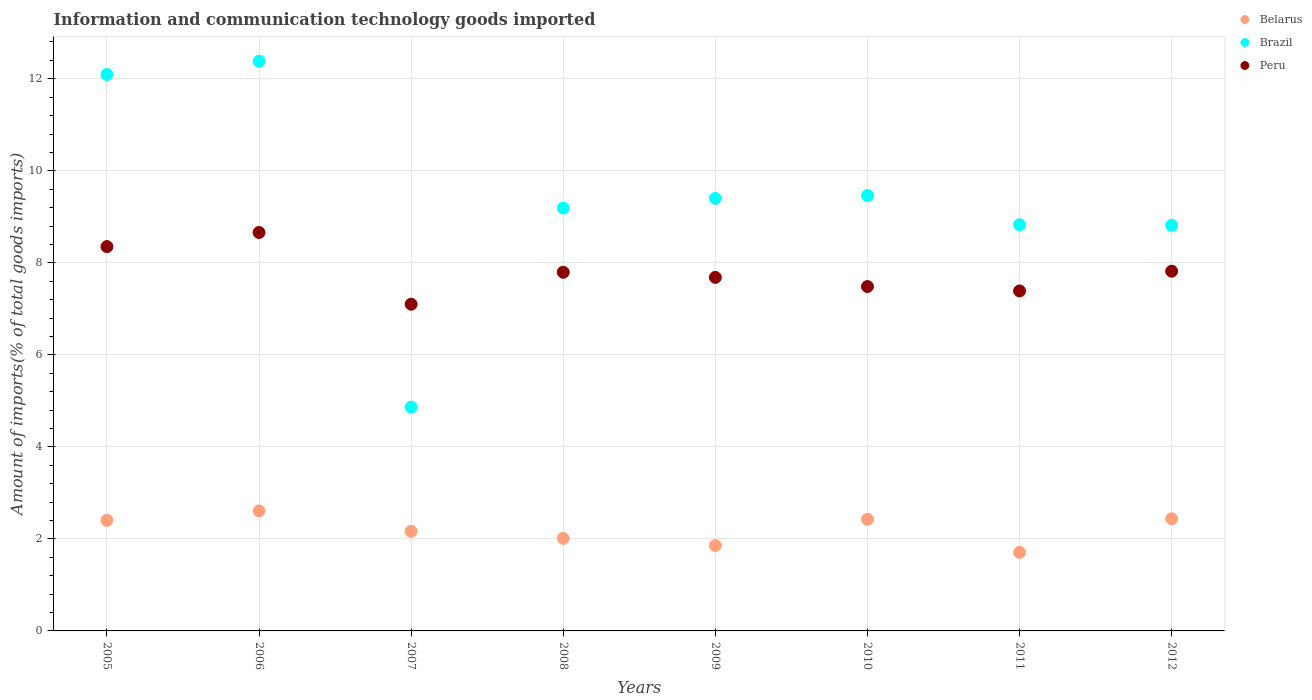Is the number of dotlines equal to the number of legend labels?
Keep it short and to the point. Yes. What is the amount of goods imported in Brazil in 2011?
Make the answer very short. 8.83. Across all years, what is the maximum amount of goods imported in Belarus?
Ensure brevity in your answer.  2.61. Across all years, what is the minimum amount of goods imported in Belarus?
Give a very brief answer. 1.71. In which year was the amount of goods imported in Brazil maximum?
Provide a succinct answer. 2006. What is the total amount of goods imported in Peru in the graph?
Ensure brevity in your answer.  62.29. What is the difference between the amount of goods imported in Peru in 2006 and that in 2007?
Give a very brief answer. 1.56. What is the difference between the amount of goods imported in Brazil in 2008 and the amount of goods imported in Belarus in 2009?
Provide a succinct answer. 7.34. What is the average amount of goods imported in Belarus per year?
Make the answer very short. 2.2. In the year 2008, what is the difference between the amount of goods imported in Belarus and amount of goods imported in Brazil?
Give a very brief answer. -7.18. In how many years, is the amount of goods imported in Peru greater than 4.8 %?
Your response must be concise. 8. What is the ratio of the amount of goods imported in Belarus in 2007 to that in 2011?
Make the answer very short. 1.27. Is the amount of goods imported in Peru in 2005 less than that in 2009?
Your answer should be very brief. No. What is the difference between the highest and the second highest amount of goods imported in Belarus?
Provide a short and direct response. 0.17. What is the difference between the highest and the lowest amount of goods imported in Belarus?
Make the answer very short. 0.9. In how many years, is the amount of goods imported in Belarus greater than the average amount of goods imported in Belarus taken over all years?
Make the answer very short. 4. Is the sum of the amount of goods imported in Belarus in 2006 and 2009 greater than the maximum amount of goods imported in Brazil across all years?
Your answer should be compact. No. Is it the case that in every year, the sum of the amount of goods imported in Peru and amount of goods imported in Belarus  is greater than the amount of goods imported in Brazil?
Offer a terse response. No. How many dotlines are there?
Offer a terse response. 3. Where does the legend appear in the graph?
Provide a succinct answer. Top right. What is the title of the graph?
Your answer should be compact. Information and communication technology goods imported. Does "Guam" appear as one of the legend labels in the graph?
Make the answer very short. No. What is the label or title of the X-axis?
Make the answer very short. Years. What is the label or title of the Y-axis?
Keep it short and to the point. Amount of imports(% of total goods imports). What is the Amount of imports(% of total goods imports) of Belarus in 2005?
Your answer should be very brief. 2.4. What is the Amount of imports(% of total goods imports) of Brazil in 2005?
Your answer should be compact. 12.1. What is the Amount of imports(% of total goods imports) in Peru in 2005?
Make the answer very short. 8.35. What is the Amount of imports(% of total goods imports) in Belarus in 2006?
Make the answer very short. 2.61. What is the Amount of imports(% of total goods imports) in Brazil in 2006?
Offer a terse response. 12.38. What is the Amount of imports(% of total goods imports) in Peru in 2006?
Your answer should be compact. 8.66. What is the Amount of imports(% of total goods imports) in Belarus in 2007?
Your answer should be compact. 2.17. What is the Amount of imports(% of total goods imports) in Brazil in 2007?
Offer a very short reply. 4.87. What is the Amount of imports(% of total goods imports) in Peru in 2007?
Offer a terse response. 7.1. What is the Amount of imports(% of total goods imports) of Belarus in 2008?
Your answer should be very brief. 2.01. What is the Amount of imports(% of total goods imports) in Brazil in 2008?
Ensure brevity in your answer.  9.19. What is the Amount of imports(% of total goods imports) in Peru in 2008?
Provide a short and direct response. 7.8. What is the Amount of imports(% of total goods imports) in Belarus in 2009?
Keep it short and to the point. 1.85. What is the Amount of imports(% of total goods imports) in Brazil in 2009?
Offer a very short reply. 9.4. What is the Amount of imports(% of total goods imports) in Peru in 2009?
Ensure brevity in your answer.  7.68. What is the Amount of imports(% of total goods imports) in Belarus in 2010?
Your response must be concise. 2.43. What is the Amount of imports(% of total goods imports) of Brazil in 2010?
Offer a very short reply. 9.46. What is the Amount of imports(% of total goods imports) of Peru in 2010?
Keep it short and to the point. 7.48. What is the Amount of imports(% of total goods imports) in Belarus in 2011?
Make the answer very short. 1.71. What is the Amount of imports(% of total goods imports) of Brazil in 2011?
Make the answer very short. 8.83. What is the Amount of imports(% of total goods imports) in Peru in 2011?
Offer a terse response. 7.39. What is the Amount of imports(% of total goods imports) of Belarus in 2012?
Keep it short and to the point. 2.44. What is the Amount of imports(% of total goods imports) of Brazil in 2012?
Keep it short and to the point. 8.82. What is the Amount of imports(% of total goods imports) in Peru in 2012?
Provide a succinct answer. 7.82. Across all years, what is the maximum Amount of imports(% of total goods imports) of Belarus?
Keep it short and to the point. 2.61. Across all years, what is the maximum Amount of imports(% of total goods imports) in Brazil?
Give a very brief answer. 12.38. Across all years, what is the maximum Amount of imports(% of total goods imports) of Peru?
Give a very brief answer. 8.66. Across all years, what is the minimum Amount of imports(% of total goods imports) of Belarus?
Offer a terse response. 1.71. Across all years, what is the minimum Amount of imports(% of total goods imports) of Brazil?
Provide a short and direct response. 4.87. Across all years, what is the minimum Amount of imports(% of total goods imports) of Peru?
Offer a very short reply. 7.1. What is the total Amount of imports(% of total goods imports) of Belarus in the graph?
Provide a short and direct response. 17.61. What is the total Amount of imports(% of total goods imports) of Brazil in the graph?
Ensure brevity in your answer.  75.04. What is the total Amount of imports(% of total goods imports) in Peru in the graph?
Your answer should be compact. 62.29. What is the difference between the Amount of imports(% of total goods imports) in Belarus in 2005 and that in 2006?
Provide a succinct answer. -0.2. What is the difference between the Amount of imports(% of total goods imports) of Brazil in 2005 and that in 2006?
Offer a very short reply. -0.29. What is the difference between the Amount of imports(% of total goods imports) in Peru in 2005 and that in 2006?
Your answer should be compact. -0.31. What is the difference between the Amount of imports(% of total goods imports) in Belarus in 2005 and that in 2007?
Give a very brief answer. 0.24. What is the difference between the Amount of imports(% of total goods imports) of Brazil in 2005 and that in 2007?
Give a very brief answer. 7.23. What is the difference between the Amount of imports(% of total goods imports) in Peru in 2005 and that in 2007?
Provide a short and direct response. 1.25. What is the difference between the Amount of imports(% of total goods imports) in Belarus in 2005 and that in 2008?
Offer a terse response. 0.39. What is the difference between the Amount of imports(% of total goods imports) in Brazil in 2005 and that in 2008?
Provide a short and direct response. 2.9. What is the difference between the Amount of imports(% of total goods imports) of Peru in 2005 and that in 2008?
Your answer should be very brief. 0.56. What is the difference between the Amount of imports(% of total goods imports) of Belarus in 2005 and that in 2009?
Make the answer very short. 0.55. What is the difference between the Amount of imports(% of total goods imports) of Brazil in 2005 and that in 2009?
Offer a very short reply. 2.69. What is the difference between the Amount of imports(% of total goods imports) in Peru in 2005 and that in 2009?
Make the answer very short. 0.67. What is the difference between the Amount of imports(% of total goods imports) in Belarus in 2005 and that in 2010?
Provide a succinct answer. -0.02. What is the difference between the Amount of imports(% of total goods imports) of Brazil in 2005 and that in 2010?
Provide a succinct answer. 2.63. What is the difference between the Amount of imports(% of total goods imports) of Peru in 2005 and that in 2010?
Offer a very short reply. 0.87. What is the difference between the Amount of imports(% of total goods imports) of Belarus in 2005 and that in 2011?
Offer a very short reply. 0.7. What is the difference between the Amount of imports(% of total goods imports) in Brazil in 2005 and that in 2011?
Your answer should be compact. 3.27. What is the difference between the Amount of imports(% of total goods imports) of Peru in 2005 and that in 2011?
Offer a very short reply. 0.96. What is the difference between the Amount of imports(% of total goods imports) in Belarus in 2005 and that in 2012?
Offer a very short reply. -0.04. What is the difference between the Amount of imports(% of total goods imports) of Brazil in 2005 and that in 2012?
Your response must be concise. 3.28. What is the difference between the Amount of imports(% of total goods imports) in Peru in 2005 and that in 2012?
Make the answer very short. 0.54. What is the difference between the Amount of imports(% of total goods imports) in Belarus in 2006 and that in 2007?
Provide a succinct answer. 0.44. What is the difference between the Amount of imports(% of total goods imports) in Brazil in 2006 and that in 2007?
Offer a very short reply. 7.52. What is the difference between the Amount of imports(% of total goods imports) in Peru in 2006 and that in 2007?
Make the answer very short. 1.56. What is the difference between the Amount of imports(% of total goods imports) in Belarus in 2006 and that in 2008?
Make the answer very short. 0.6. What is the difference between the Amount of imports(% of total goods imports) of Brazil in 2006 and that in 2008?
Your answer should be compact. 3.19. What is the difference between the Amount of imports(% of total goods imports) in Peru in 2006 and that in 2008?
Your answer should be compact. 0.86. What is the difference between the Amount of imports(% of total goods imports) in Belarus in 2006 and that in 2009?
Ensure brevity in your answer.  0.75. What is the difference between the Amount of imports(% of total goods imports) in Brazil in 2006 and that in 2009?
Offer a terse response. 2.98. What is the difference between the Amount of imports(% of total goods imports) in Peru in 2006 and that in 2009?
Offer a terse response. 0.98. What is the difference between the Amount of imports(% of total goods imports) of Belarus in 2006 and that in 2010?
Ensure brevity in your answer.  0.18. What is the difference between the Amount of imports(% of total goods imports) of Brazil in 2006 and that in 2010?
Your answer should be compact. 2.92. What is the difference between the Amount of imports(% of total goods imports) of Peru in 2006 and that in 2010?
Your answer should be compact. 1.17. What is the difference between the Amount of imports(% of total goods imports) in Belarus in 2006 and that in 2011?
Provide a succinct answer. 0.9. What is the difference between the Amount of imports(% of total goods imports) in Brazil in 2006 and that in 2011?
Ensure brevity in your answer.  3.56. What is the difference between the Amount of imports(% of total goods imports) in Peru in 2006 and that in 2011?
Your response must be concise. 1.27. What is the difference between the Amount of imports(% of total goods imports) in Belarus in 2006 and that in 2012?
Provide a succinct answer. 0.17. What is the difference between the Amount of imports(% of total goods imports) in Brazil in 2006 and that in 2012?
Ensure brevity in your answer.  3.57. What is the difference between the Amount of imports(% of total goods imports) of Peru in 2006 and that in 2012?
Your answer should be compact. 0.84. What is the difference between the Amount of imports(% of total goods imports) of Belarus in 2007 and that in 2008?
Provide a succinct answer. 0.15. What is the difference between the Amount of imports(% of total goods imports) in Brazil in 2007 and that in 2008?
Your answer should be very brief. -4.33. What is the difference between the Amount of imports(% of total goods imports) in Peru in 2007 and that in 2008?
Offer a very short reply. -0.69. What is the difference between the Amount of imports(% of total goods imports) in Belarus in 2007 and that in 2009?
Your answer should be very brief. 0.31. What is the difference between the Amount of imports(% of total goods imports) in Brazil in 2007 and that in 2009?
Make the answer very short. -4.54. What is the difference between the Amount of imports(% of total goods imports) of Peru in 2007 and that in 2009?
Offer a very short reply. -0.58. What is the difference between the Amount of imports(% of total goods imports) of Belarus in 2007 and that in 2010?
Offer a terse response. -0.26. What is the difference between the Amount of imports(% of total goods imports) of Brazil in 2007 and that in 2010?
Give a very brief answer. -4.6. What is the difference between the Amount of imports(% of total goods imports) of Peru in 2007 and that in 2010?
Offer a terse response. -0.38. What is the difference between the Amount of imports(% of total goods imports) in Belarus in 2007 and that in 2011?
Your answer should be very brief. 0.46. What is the difference between the Amount of imports(% of total goods imports) in Brazil in 2007 and that in 2011?
Ensure brevity in your answer.  -3.96. What is the difference between the Amount of imports(% of total goods imports) in Peru in 2007 and that in 2011?
Provide a succinct answer. -0.29. What is the difference between the Amount of imports(% of total goods imports) of Belarus in 2007 and that in 2012?
Offer a very short reply. -0.27. What is the difference between the Amount of imports(% of total goods imports) in Brazil in 2007 and that in 2012?
Provide a succinct answer. -3.95. What is the difference between the Amount of imports(% of total goods imports) in Peru in 2007 and that in 2012?
Provide a succinct answer. -0.72. What is the difference between the Amount of imports(% of total goods imports) of Belarus in 2008 and that in 2009?
Your answer should be compact. 0.16. What is the difference between the Amount of imports(% of total goods imports) of Brazil in 2008 and that in 2009?
Your response must be concise. -0.21. What is the difference between the Amount of imports(% of total goods imports) of Peru in 2008 and that in 2009?
Give a very brief answer. 0.11. What is the difference between the Amount of imports(% of total goods imports) of Belarus in 2008 and that in 2010?
Provide a short and direct response. -0.41. What is the difference between the Amount of imports(% of total goods imports) in Brazil in 2008 and that in 2010?
Keep it short and to the point. -0.27. What is the difference between the Amount of imports(% of total goods imports) in Peru in 2008 and that in 2010?
Offer a terse response. 0.31. What is the difference between the Amount of imports(% of total goods imports) in Belarus in 2008 and that in 2011?
Provide a succinct answer. 0.3. What is the difference between the Amount of imports(% of total goods imports) of Brazil in 2008 and that in 2011?
Provide a succinct answer. 0.36. What is the difference between the Amount of imports(% of total goods imports) of Peru in 2008 and that in 2011?
Your response must be concise. 0.41. What is the difference between the Amount of imports(% of total goods imports) in Belarus in 2008 and that in 2012?
Keep it short and to the point. -0.43. What is the difference between the Amount of imports(% of total goods imports) of Brazil in 2008 and that in 2012?
Make the answer very short. 0.38. What is the difference between the Amount of imports(% of total goods imports) of Peru in 2008 and that in 2012?
Keep it short and to the point. -0.02. What is the difference between the Amount of imports(% of total goods imports) in Belarus in 2009 and that in 2010?
Make the answer very short. -0.57. What is the difference between the Amount of imports(% of total goods imports) of Brazil in 2009 and that in 2010?
Ensure brevity in your answer.  -0.06. What is the difference between the Amount of imports(% of total goods imports) in Peru in 2009 and that in 2010?
Your response must be concise. 0.2. What is the difference between the Amount of imports(% of total goods imports) in Belarus in 2009 and that in 2011?
Provide a succinct answer. 0.15. What is the difference between the Amount of imports(% of total goods imports) of Brazil in 2009 and that in 2011?
Your answer should be compact. 0.57. What is the difference between the Amount of imports(% of total goods imports) in Peru in 2009 and that in 2011?
Your answer should be very brief. 0.29. What is the difference between the Amount of imports(% of total goods imports) in Belarus in 2009 and that in 2012?
Keep it short and to the point. -0.58. What is the difference between the Amount of imports(% of total goods imports) in Brazil in 2009 and that in 2012?
Offer a very short reply. 0.59. What is the difference between the Amount of imports(% of total goods imports) in Peru in 2009 and that in 2012?
Provide a succinct answer. -0.13. What is the difference between the Amount of imports(% of total goods imports) in Belarus in 2010 and that in 2011?
Give a very brief answer. 0.72. What is the difference between the Amount of imports(% of total goods imports) of Brazil in 2010 and that in 2011?
Your answer should be very brief. 0.64. What is the difference between the Amount of imports(% of total goods imports) in Peru in 2010 and that in 2011?
Provide a succinct answer. 0.09. What is the difference between the Amount of imports(% of total goods imports) in Belarus in 2010 and that in 2012?
Your response must be concise. -0.01. What is the difference between the Amount of imports(% of total goods imports) of Brazil in 2010 and that in 2012?
Ensure brevity in your answer.  0.65. What is the difference between the Amount of imports(% of total goods imports) of Peru in 2010 and that in 2012?
Ensure brevity in your answer.  -0.33. What is the difference between the Amount of imports(% of total goods imports) of Belarus in 2011 and that in 2012?
Provide a succinct answer. -0.73. What is the difference between the Amount of imports(% of total goods imports) in Brazil in 2011 and that in 2012?
Make the answer very short. 0.01. What is the difference between the Amount of imports(% of total goods imports) of Peru in 2011 and that in 2012?
Ensure brevity in your answer.  -0.43. What is the difference between the Amount of imports(% of total goods imports) in Belarus in 2005 and the Amount of imports(% of total goods imports) in Brazil in 2006?
Keep it short and to the point. -9.98. What is the difference between the Amount of imports(% of total goods imports) of Belarus in 2005 and the Amount of imports(% of total goods imports) of Peru in 2006?
Your response must be concise. -6.26. What is the difference between the Amount of imports(% of total goods imports) in Brazil in 2005 and the Amount of imports(% of total goods imports) in Peru in 2006?
Your response must be concise. 3.44. What is the difference between the Amount of imports(% of total goods imports) of Belarus in 2005 and the Amount of imports(% of total goods imports) of Brazil in 2007?
Make the answer very short. -2.46. What is the difference between the Amount of imports(% of total goods imports) in Belarus in 2005 and the Amount of imports(% of total goods imports) in Peru in 2007?
Your answer should be compact. -4.7. What is the difference between the Amount of imports(% of total goods imports) of Brazil in 2005 and the Amount of imports(% of total goods imports) of Peru in 2007?
Keep it short and to the point. 4.99. What is the difference between the Amount of imports(% of total goods imports) of Belarus in 2005 and the Amount of imports(% of total goods imports) of Brazil in 2008?
Provide a short and direct response. -6.79. What is the difference between the Amount of imports(% of total goods imports) in Belarus in 2005 and the Amount of imports(% of total goods imports) in Peru in 2008?
Make the answer very short. -5.39. What is the difference between the Amount of imports(% of total goods imports) in Brazil in 2005 and the Amount of imports(% of total goods imports) in Peru in 2008?
Offer a terse response. 4.3. What is the difference between the Amount of imports(% of total goods imports) in Belarus in 2005 and the Amount of imports(% of total goods imports) in Brazil in 2009?
Offer a very short reply. -7. What is the difference between the Amount of imports(% of total goods imports) in Belarus in 2005 and the Amount of imports(% of total goods imports) in Peru in 2009?
Offer a very short reply. -5.28. What is the difference between the Amount of imports(% of total goods imports) in Brazil in 2005 and the Amount of imports(% of total goods imports) in Peru in 2009?
Make the answer very short. 4.41. What is the difference between the Amount of imports(% of total goods imports) in Belarus in 2005 and the Amount of imports(% of total goods imports) in Brazil in 2010?
Offer a terse response. -7.06. What is the difference between the Amount of imports(% of total goods imports) in Belarus in 2005 and the Amount of imports(% of total goods imports) in Peru in 2010?
Give a very brief answer. -5.08. What is the difference between the Amount of imports(% of total goods imports) of Brazil in 2005 and the Amount of imports(% of total goods imports) of Peru in 2010?
Your answer should be very brief. 4.61. What is the difference between the Amount of imports(% of total goods imports) in Belarus in 2005 and the Amount of imports(% of total goods imports) in Brazil in 2011?
Provide a succinct answer. -6.42. What is the difference between the Amount of imports(% of total goods imports) of Belarus in 2005 and the Amount of imports(% of total goods imports) of Peru in 2011?
Keep it short and to the point. -4.99. What is the difference between the Amount of imports(% of total goods imports) of Brazil in 2005 and the Amount of imports(% of total goods imports) of Peru in 2011?
Ensure brevity in your answer.  4.71. What is the difference between the Amount of imports(% of total goods imports) in Belarus in 2005 and the Amount of imports(% of total goods imports) in Brazil in 2012?
Offer a terse response. -6.41. What is the difference between the Amount of imports(% of total goods imports) of Belarus in 2005 and the Amount of imports(% of total goods imports) of Peru in 2012?
Ensure brevity in your answer.  -5.41. What is the difference between the Amount of imports(% of total goods imports) in Brazil in 2005 and the Amount of imports(% of total goods imports) in Peru in 2012?
Your answer should be compact. 4.28. What is the difference between the Amount of imports(% of total goods imports) in Belarus in 2006 and the Amount of imports(% of total goods imports) in Brazil in 2007?
Your response must be concise. -2.26. What is the difference between the Amount of imports(% of total goods imports) of Belarus in 2006 and the Amount of imports(% of total goods imports) of Peru in 2007?
Offer a terse response. -4.49. What is the difference between the Amount of imports(% of total goods imports) in Brazil in 2006 and the Amount of imports(% of total goods imports) in Peru in 2007?
Provide a short and direct response. 5.28. What is the difference between the Amount of imports(% of total goods imports) of Belarus in 2006 and the Amount of imports(% of total goods imports) of Brazil in 2008?
Ensure brevity in your answer.  -6.58. What is the difference between the Amount of imports(% of total goods imports) in Belarus in 2006 and the Amount of imports(% of total goods imports) in Peru in 2008?
Keep it short and to the point. -5.19. What is the difference between the Amount of imports(% of total goods imports) in Brazil in 2006 and the Amount of imports(% of total goods imports) in Peru in 2008?
Make the answer very short. 4.59. What is the difference between the Amount of imports(% of total goods imports) in Belarus in 2006 and the Amount of imports(% of total goods imports) in Brazil in 2009?
Keep it short and to the point. -6.79. What is the difference between the Amount of imports(% of total goods imports) of Belarus in 2006 and the Amount of imports(% of total goods imports) of Peru in 2009?
Make the answer very short. -5.08. What is the difference between the Amount of imports(% of total goods imports) in Brazil in 2006 and the Amount of imports(% of total goods imports) in Peru in 2009?
Provide a succinct answer. 4.7. What is the difference between the Amount of imports(% of total goods imports) in Belarus in 2006 and the Amount of imports(% of total goods imports) in Brazil in 2010?
Offer a terse response. -6.86. What is the difference between the Amount of imports(% of total goods imports) of Belarus in 2006 and the Amount of imports(% of total goods imports) of Peru in 2010?
Offer a very short reply. -4.88. What is the difference between the Amount of imports(% of total goods imports) of Brazil in 2006 and the Amount of imports(% of total goods imports) of Peru in 2010?
Make the answer very short. 4.9. What is the difference between the Amount of imports(% of total goods imports) in Belarus in 2006 and the Amount of imports(% of total goods imports) in Brazil in 2011?
Provide a short and direct response. -6.22. What is the difference between the Amount of imports(% of total goods imports) of Belarus in 2006 and the Amount of imports(% of total goods imports) of Peru in 2011?
Provide a succinct answer. -4.78. What is the difference between the Amount of imports(% of total goods imports) in Brazil in 2006 and the Amount of imports(% of total goods imports) in Peru in 2011?
Make the answer very short. 4.99. What is the difference between the Amount of imports(% of total goods imports) of Belarus in 2006 and the Amount of imports(% of total goods imports) of Brazil in 2012?
Keep it short and to the point. -6.21. What is the difference between the Amount of imports(% of total goods imports) in Belarus in 2006 and the Amount of imports(% of total goods imports) in Peru in 2012?
Your answer should be very brief. -5.21. What is the difference between the Amount of imports(% of total goods imports) in Brazil in 2006 and the Amount of imports(% of total goods imports) in Peru in 2012?
Keep it short and to the point. 4.57. What is the difference between the Amount of imports(% of total goods imports) of Belarus in 2007 and the Amount of imports(% of total goods imports) of Brazil in 2008?
Ensure brevity in your answer.  -7.03. What is the difference between the Amount of imports(% of total goods imports) in Belarus in 2007 and the Amount of imports(% of total goods imports) in Peru in 2008?
Make the answer very short. -5.63. What is the difference between the Amount of imports(% of total goods imports) of Brazil in 2007 and the Amount of imports(% of total goods imports) of Peru in 2008?
Offer a very short reply. -2.93. What is the difference between the Amount of imports(% of total goods imports) in Belarus in 2007 and the Amount of imports(% of total goods imports) in Brazil in 2009?
Your answer should be compact. -7.24. What is the difference between the Amount of imports(% of total goods imports) of Belarus in 2007 and the Amount of imports(% of total goods imports) of Peru in 2009?
Provide a succinct answer. -5.52. What is the difference between the Amount of imports(% of total goods imports) in Brazil in 2007 and the Amount of imports(% of total goods imports) in Peru in 2009?
Offer a terse response. -2.82. What is the difference between the Amount of imports(% of total goods imports) of Belarus in 2007 and the Amount of imports(% of total goods imports) of Brazil in 2010?
Your answer should be very brief. -7.3. What is the difference between the Amount of imports(% of total goods imports) of Belarus in 2007 and the Amount of imports(% of total goods imports) of Peru in 2010?
Give a very brief answer. -5.32. What is the difference between the Amount of imports(% of total goods imports) of Brazil in 2007 and the Amount of imports(% of total goods imports) of Peru in 2010?
Ensure brevity in your answer.  -2.62. What is the difference between the Amount of imports(% of total goods imports) of Belarus in 2007 and the Amount of imports(% of total goods imports) of Brazil in 2011?
Provide a succinct answer. -6.66. What is the difference between the Amount of imports(% of total goods imports) of Belarus in 2007 and the Amount of imports(% of total goods imports) of Peru in 2011?
Ensure brevity in your answer.  -5.22. What is the difference between the Amount of imports(% of total goods imports) in Brazil in 2007 and the Amount of imports(% of total goods imports) in Peru in 2011?
Provide a succinct answer. -2.52. What is the difference between the Amount of imports(% of total goods imports) in Belarus in 2007 and the Amount of imports(% of total goods imports) in Brazil in 2012?
Offer a very short reply. -6.65. What is the difference between the Amount of imports(% of total goods imports) in Belarus in 2007 and the Amount of imports(% of total goods imports) in Peru in 2012?
Your response must be concise. -5.65. What is the difference between the Amount of imports(% of total goods imports) of Brazil in 2007 and the Amount of imports(% of total goods imports) of Peru in 2012?
Give a very brief answer. -2.95. What is the difference between the Amount of imports(% of total goods imports) in Belarus in 2008 and the Amount of imports(% of total goods imports) in Brazil in 2009?
Your response must be concise. -7.39. What is the difference between the Amount of imports(% of total goods imports) of Belarus in 2008 and the Amount of imports(% of total goods imports) of Peru in 2009?
Your answer should be very brief. -5.67. What is the difference between the Amount of imports(% of total goods imports) of Brazil in 2008 and the Amount of imports(% of total goods imports) of Peru in 2009?
Make the answer very short. 1.51. What is the difference between the Amount of imports(% of total goods imports) of Belarus in 2008 and the Amount of imports(% of total goods imports) of Brazil in 2010?
Give a very brief answer. -7.45. What is the difference between the Amount of imports(% of total goods imports) in Belarus in 2008 and the Amount of imports(% of total goods imports) in Peru in 2010?
Your response must be concise. -5.47. What is the difference between the Amount of imports(% of total goods imports) in Brazil in 2008 and the Amount of imports(% of total goods imports) in Peru in 2010?
Provide a succinct answer. 1.71. What is the difference between the Amount of imports(% of total goods imports) of Belarus in 2008 and the Amount of imports(% of total goods imports) of Brazil in 2011?
Your response must be concise. -6.82. What is the difference between the Amount of imports(% of total goods imports) of Belarus in 2008 and the Amount of imports(% of total goods imports) of Peru in 2011?
Give a very brief answer. -5.38. What is the difference between the Amount of imports(% of total goods imports) of Brazil in 2008 and the Amount of imports(% of total goods imports) of Peru in 2011?
Your answer should be very brief. 1.8. What is the difference between the Amount of imports(% of total goods imports) in Belarus in 2008 and the Amount of imports(% of total goods imports) in Brazil in 2012?
Ensure brevity in your answer.  -6.8. What is the difference between the Amount of imports(% of total goods imports) in Belarus in 2008 and the Amount of imports(% of total goods imports) in Peru in 2012?
Provide a succinct answer. -5.81. What is the difference between the Amount of imports(% of total goods imports) in Brazil in 2008 and the Amount of imports(% of total goods imports) in Peru in 2012?
Provide a short and direct response. 1.37. What is the difference between the Amount of imports(% of total goods imports) of Belarus in 2009 and the Amount of imports(% of total goods imports) of Brazil in 2010?
Keep it short and to the point. -7.61. What is the difference between the Amount of imports(% of total goods imports) in Belarus in 2009 and the Amount of imports(% of total goods imports) in Peru in 2010?
Your answer should be compact. -5.63. What is the difference between the Amount of imports(% of total goods imports) in Brazil in 2009 and the Amount of imports(% of total goods imports) in Peru in 2010?
Provide a short and direct response. 1.92. What is the difference between the Amount of imports(% of total goods imports) in Belarus in 2009 and the Amount of imports(% of total goods imports) in Brazil in 2011?
Your response must be concise. -6.97. What is the difference between the Amount of imports(% of total goods imports) in Belarus in 2009 and the Amount of imports(% of total goods imports) in Peru in 2011?
Offer a very short reply. -5.54. What is the difference between the Amount of imports(% of total goods imports) of Brazil in 2009 and the Amount of imports(% of total goods imports) of Peru in 2011?
Your answer should be very brief. 2.01. What is the difference between the Amount of imports(% of total goods imports) of Belarus in 2009 and the Amount of imports(% of total goods imports) of Brazil in 2012?
Make the answer very short. -6.96. What is the difference between the Amount of imports(% of total goods imports) in Belarus in 2009 and the Amount of imports(% of total goods imports) in Peru in 2012?
Offer a terse response. -5.96. What is the difference between the Amount of imports(% of total goods imports) of Brazil in 2009 and the Amount of imports(% of total goods imports) of Peru in 2012?
Your response must be concise. 1.58. What is the difference between the Amount of imports(% of total goods imports) in Belarus in 2010 and the Amount of imports(% of total goods imports) in Brazil in 2011?
Give a very brief answer. -6.4. What is the difference between the Amount of imports(% of total goods imports) in Belarus in 2010 and the Amount of imports(% of total goods imports) in Peru in 2011?
Ensure brevity in your answer.  -4.96. What is the difference between the Amount of imports(% of total goods imports) of Brazil in 2010 and the Amount of imports(% of total goods imports) of Peru in 2011?
Provide a succinct answer. 2.07. What is the difference between the Amount of imports(% of total goods imports) of Belarus in 2010 and the Amount of imports(% of total goods imports) of Brazil in 2012?
Provide a succinct answer. -6.39. What is the difference between the Amount of imports(% of total goods imports) in Belarus in 2010 and the Amount of imports(% of total goods imports) in Peru in 2012?
Give a very brief answer. -5.39. What is the difference between the Amount of imports(% of total goods imports) in Brazil in 2010 and the Amount of imports(% of total goods imports) in Peru in 2012?
Offer a very short reply. 1.65. What is the difference between the Amount of imports(% of total goods imports) of Belarus in 2011 and the Amount of imports(% of total goods imports) of Brazil in 2012?
Your answer should be very brief. -7.11. What is the difference between the Amount of imports(% of total goods imports) of Belarus in 2011 and the Amount of imports(% of total goods imports) of Peru in 2012?
Ensure brevity in your answer.  -6.11. What is the difference between the Amount of imports(% of total goods imports) of Brazil in 2011 and the Amount of imports(% of total goods imports) of Peru in 2012?
Make the answer very short. 1.01. What is the average Amount of imports(% of total goods imports) of Belarus per year?
Offer a very short reply. 2.2. What is the average Amount of imports(% of total goods imports) of Brazil per year?
Provide a short and direct response. 9.38. What is the average Amount of imports(% of total goods imports) of Peru per year?
Provide a succinct answer. 7.79. In the year 2005, what is the difference between the Amount of imports(% of total goods imports) in Belarus and Amount of imports(% of total goods imports) in Brazil?
Provide a short and direct response. -9.69. In the year 2005, what is the difference between the Amount of imports(% of total goods imports) in Belarus and Amount of imports(% of total goods imports) in Peru?
Ensure brevity in your answer.  -5.95. In the year 2005, what is the difference between the Amount of imports(% of total goods imports) of Brazil and Amount of imports(% of total goods imports) of Peru?
Give a very brief answer. 3.74. In the year 2006, what is the difference between the Amount of imports(% of total goods imports) in Belarus and Amount of imports(% of total goods imports) in Brazil?
Provide a short and direct response. -9.78. In the year 2006, what is the difference between the Amount of imports(% of total goods imports) in Belarus and Amount of imports(% of total goods imports) in Peru?
Provide a short and direct response. -6.05. In the year 2006, what is the difference between the Amount of imports(% of total goods imports) in Brazil and Amount of imports(% of total goods imports) in Peru?
Make the answer very short. 3.72. In the year 2007, what is the difference between the Amount of imports(% of total goods imports) of Belarus and Amount of imports(% of total goods imports) of Brazil?
Provide a succinct answer. -2.7. In the year 2007, what is the difference between the Amount of imports(% of total goods imports) in Belarus and Amount of imports(% of total goods imports) in Peru?
Your answer should be very brief. -4.94. In the year 2007, what is the difference between the Amount of imports(% of total goods imports) in Brazil and Amount of imports(% of total goods imports) in Peru?
Make the answer very short. -2.24. In the year 2008, what is the difference between the Amount of imports(% of total goods imports) in Belarus and Amount of imports(% of total goods imports) in Brazil?
Your answer should be compact. -7.18. In the year 2008, what is the difference between the Amount of imports(% of total goods imports) of Belarus and Amount of imports(% of total goods imports) of Peru?
Offer a terse response. -5.78. In the year 2008, what is the difference between the Amount of imports(% of total goods imports) in Brazil and Amount of imports(% of total goods imports) in Peru?
Offer a terse response. 1.4. In the year 2009, what is the difference between the Amount of imports(% of total goods imports) of Belarus and Amount of imports(% of total goods imports) of Brazil?
Provide a short and direct response. -7.55. In the year 2009, what is the difference between the Amount of imports(% of total goods imports) of Belarus and Amount of imports(% of total goods imports) of Peru?
Your answer should be compact. -5.83. In the year 2009, what is the difference between the Amount of imports(% of total goods imports) of Brazil and Amount of imports(% of total goods imports) of Peru?
Provide a succinct answer. 1.72. In the year 2010, what is the difference between the Amount of imports(% of total goods imports) in Belarus and Amount of imports(% of total goods imports) in Brazil?
Make the answer very short. -7.04. In the year 2010, what is the difference between the Amount of imports(% of total goods imports) of Belarus and Amount of imports(% of total goods imports) of Peru?
Make the answer very short. -5.06. In the year 2010, what is the difference between the Amount of imports(% of total goods imports) in Brazil and Amount of imports(% of total goods imports) in Peru?
Your answer should be compact. 1.98. In the year 2011, what is the difference between the Amount of imports(% of total goods imports) in Belarus and Amount of imports(% of total goods imports) in Brazil?
Keep it short and to the point. -7.12. In the year 2011, what is the difference between the Amount of imports(% of total goods imports) in Belarus and Amount of imports(% of total goods imports) in Peru?
Make the answer very short. -5.68. In the year 2011, what is the difference between the Amount of imports(% of total goods imports) in Brazil and Amount of imports(% of total goods imports) in Peru?
Keep it short and to the point. 1.44. In the year 2012, what is the difference between the Amount of imports(% of total goods imports) in Belarus and Amount of imports(% of total goods imports) in Brazil?
Offer a terse response. -6.38. In the year 2012, what is the difference between the Amount of imports(% of total goods imports) of Belarus and Amount of imports(% of total goods imports) of Peru?
Give a very brief answer. -5.38. In the year 2012, what is the difference between the Amount of imports(% of total goods imports) of Brazil and Amount of imports(% of total goods imports) of Peru?
Offer a very short reply. 1. What is the ratio of the Amount of imports(% of total goods imports) of Belarus in 2005 to that in 2006?
Keep it short and to the point. 0.92. What is the ratio of the Amount of imports(% of total goods imports) in Brazil in 2005 to that in 2006?
Provide a succinct answer. 0.98. What is the ratio of the Amount of imports(% of total goods imports) in Peru in 2005 to that in 2006?
Make the answer very short. 0.96. What is the ratio of the Amount of imports(% of total goods imports) of Belarus in 2005 to that in 2007?
Give a very brief answer. 1.11. What is the ratio of the Amount of imports(% of total goods imports) in Brazil in 2005 to that in 2007?
Keep it short and to the point. 2.49. What is the ratio of the Amount of imports(% of total goods imports) in Peru in 2005 to that in 2007?
Make the answer very short. 1.18. What is the ratio of the Amount of imports(% of total goods imports) in Belarus in 2005 to that in 2008?
Give a very brief answer. 1.19. What is the ratio of the Amount of imports(% of total goods imports) of Brazil in 2005 to that in 2008?
Offer a very short reply. 1.32. What is the ratio of the Amount of imports(% of total goods imports) in Peru in 2005 to that in 2008?
Provide a succinct answer. 1.07. What is the ratio of the Amount of imports(% of total goods imports) of Belarus in 2005 to that in 2009?
Your answer should be very brief. 1.3. What is the ratio of the Amount of imports(% of total goods imports) in Brazil in 2005 to that in 2009?
Offer a very short reply. 1.29. What is the ratio of the Amount of imports(% of total goods imports) of Peru in 2005 to that in 2009?
Provide a short and direct response. 1.09. What is the ratio of the Amount of imports(% of total goods imports) in Belarus in 2005 to that in 2010?
Make the answer very short. 0.99. What is the ratio of the Amount of imports(% of total goods imports) in Brazil in 2005 to that in 2010?
Your answer should be compact. 1.28. What is the ratio of the Amount of imports(% of total goods imports) of Peru in 2005 to that in 2010?
Offer a terse response. 1.12. What is the ratio of the Amount of imports(% of total goods imports) of Belarus in 2005 to that in 2011?
Keep it short and to the point. 1.41. What is the ratio of the Amount of imports(% of total goods imports) of Brazil in 2005 to that in 2011?
Offer a terse response. 1.37. What is the ratio of the Amount of imports(% of total goods imports) in Peru in 2005 to that in 2011?
Ensure brevity in your answer.  1.13. What is the ratio of the Amount of imports(% of total goods imports) in Belarus in 2005 to that in 2012?
Give a very brief answer. 0.99. What is the ratio of the Amount of imports(% of total goods imports) of Brazil in 2005 to that in 2012?
Make the answer very short. 1.37. What is the ratio of the Amount of imports(% of total goods imports) in Peru in 2005 to that in 2012?
Give a very brief answer. 1.07. What is the ratio of the Amount of imports(% of total goods imports) in Belarus in 2006 to that in 2007?
Your answer should be very brief. 1.2. What is the ratio of the Amount of imports(% of total goods imports) of Brazil in 2006 to that in 2007?
Make the answer very short. 2.55. What is the ratio of the Amount of imports(% of total goods imports) in Peru in 2006 to that in 2007?
Your answer should be very brief. 1.22. What is the ratio of the Amount of imports(% of total goods imports) in Belarus in 2006 to that in 2008?
Your answer should be compact. 1.3. What is the ratio of the Amount of imports(% of total goods imports) in Brazil in 2006 to that in 2008?
Your response must be concise. 1.35. What is the ratio of the Amount of imports(% of total goods imports) of Peru in 2006 to that in 2008?
Provide a short and direct response. 1.11. What is the ratio of the Amount of imports(% of total goods imports) of Belarus in 2006 to that in 2009?
Offer a terse response. 1.41. What is the ratio of the Amount of imports(% of total goods imports) of Brazil in 2006 to that in 2009?
Offer a very short reply. 1.32. What is the ratio of the Amount of imports(% of total goods imports) of Peru in 2006 to that in 2009?
Keep it short and to the point. 1.13. What is the ratio of the Amount of imports(% of total goods imports) of Belarus in 2006 to that in 2010?
Offer a terse response. 1.07. What is the ratio of the Amount of imports(% of total goods imports) in Brazil in 2006 to that in 2010?
Provide a succinct answer. 1.31. What is the ratio of the Amount of imports(% of total goods imports) of Peru in 2006 to that in 2010?
Provide a succinct answer. 1.16. What is the ratio of the Amount of imports(% of total goods imports) of Belarus in 2006 to that in 2011?
Offer a very short reply. 1.53. What is the ratio of the Amount of imports(% of total goods imports) of Brazil in 2006 to that in 2011?
Offer a terse response. 1.4. What is the ratio of the Amount of imports(% of total goods imports) of Peru in 2006 to that in 2011?
Your answer should be compact. 1.17. What is the ratio of the Amount of imports(% of total goods imports) in Belarus in 2006 to that in 2012?
Give a very brief answer. 1.07. What is the ratio of the Amount of imports(% of total goods imports) of Brazil in 2006 to that in 2012?
Keep it short and to the point. 1.4. What is the ratio of the Amount of imports(% of total goods imports) of Peru in 2006 to that in 2012?
Provide a succinct answer. 1.11. What is the ratio of the Amount of imports(% of total goods imports) of Belarus in 2007 to that in 2008?
Offer a terse response. 1.08. What is the ratio of the Amount of imports(% of total goods imports) of Brazil in 2007 to that in 2008?
Your response must be concise. 0.53. What is the ratio of the Amount of imports(% of total goods imports) of Peru in 2007 to that in 2008?
Make the answer very short. 0.91. What is the ratio of the Amount of imports(% of total goods imports) in Belarus in 2007 to that in 2009?
Offer a terse response. 1.17. What is the ratio of the Amount of imports(% of total goods imports) in Brazil in 2007 to that in 2009?
Your answer should be very brief. 0.52. What is the ratio of the Amount of imports(% of total goods imports) of Peru in 2007 to that in 2009?
Offer a very short reply. 0.92. What is the ratio of the Amount of imports(% of total goods imports) of Belarus in 2007 to that in 2010?
Your answer should be compact. 0.89. What is the ratio of the Amount of imports(% of total goods imports) in Brazil in 2007 to that in 2010?
Your answer should be compact. 0.51. What is the ratio of the Amount of imports(% of total goods imports) in Peru in 2007 to that in 2010?
Provide a short and direct response. 0.95. What is the ratio of the Amount of imports(% of total goods imports) in Belarus in 2007 to that in 2011?
Keep it short and to the point. 1.27. What is the ratio of the Amount of imports(% of total goods imports) in Brazil in 2007 to that in 2011?
Offer a terse response. 0.55. What is the ratio of the Amount of imports(% of total goods imports) of Peru in 2007 to that in 2011?
Offer a very short reply. 0.96. What is the ratio of the Amount of imports(% of total goods imports) of Belarus in 2007 to that in 2012?
Make the answer very short. 0.89. What is the ratio of the Amount of imports(% of total goods imports) in Brazil in 2007 to that in 2012?
Give a very brief answer. 0.55. What is the ratio of the Amount of imports(% of total goods imports) in Peru in 2007 to that in 2012?
Your answer should be compact. 0.91. What is the ratio of the Amount of imports(% of total goods imports) of Belarus in 2008 to that in 2009?
Offer a terse response. 1.08. What is the ratio of the Amount of imports(% of total goods imports) of Brazil in 2008 to that in 2009?
Make the answer very short. 0.98. What is the ratio of the Amount of imports(% of total goods imports) in Peru in 2008 to that in 2009?
Keep it short and to the point. 1.01. What is the ratio of the Amount of imports(% of total goods imports) in Belarus in 2008 to that in 2010?
Offer a very short reply. 0.83. What is the ratio of the Amount of imports(% of total goods imports) in Brazil in 2008 to that in 2010?
Provide a succinct answer. 0.97. What is the ratio of the Amount of imports(% of total goods imports) of Peru in 2008 to that in 2010?
Your answer should be compact. 1.04. What is the ratio of the Amount of imports(% of total goods imports) of Belarus in 2008 to that in 2011?
Keep it short and to the point. 1.18. What is the ratio of the Amount of imports(% of total goods imports) of Brazil in 2008 to that in 2011?
Your answer should be compact. 1.04. What is the ratio of the Amount of imports(% of total goods imports) in Peru in 2008 to that in 2011?
Give a very brief answer. 1.05. What is the ratio of the Amount of imports(% of total goods imports) of Belarus in 2008 to that in 2012?
Give a very brief answer. 0.82. What is the ratio of the Amount of imports(% of total goods imports) of Brazil in 2008 to that in 2012?
Your answer should be compact. 1.04. What is the ratio of the Amount of imports(% of total goods imports) in Belarus in 2009 to that in 2010?
Offer a terse response. 0.76. What is the ratio of the Amount of imports(% of total goods imports) in Brazil in 2009 to that in 2010?
Provide a short and direct response. 0.99. What is the ratio of the Amount of imports(% of total goods imports) in Peru in 2009 to that in 2010?
Your response must be concise. 1.03. What is the ratio of the Amount of imports(% of total goods imports) in Belarus in 2009 to that in 2011?
Ensure brevity in your answer.  1.09. What is the ratio of the Amount of imports(% of total goods imports) of Brazil in 2009 to that in 2011?
Your response must be concise. 1.06. What is the ratio of the Amount of imports(% of total goods imports) of Peru in 2009 to that in 2011?
Make the answer very short. 1.04. What is the ratio of the Amount of imports(% of total goods imports) of Belarus in 2009 to that in 2012?
Ensure brevity in your answer.  0.76. What is the ratio of the Amount of imports(% of total goods imports) of Brazil in 2009 to that in 2012?
Provide a short and direct response. 1.07. What is the ratio of the Amount of imports(% of total goods imports) of Peru in 2009 to that in 2012?
Give a very brief answer. 0.98. What is the ratio of the Amount of imports(% of total goods imports) in Belarus in 2010 to that in 2011?
Offer a terse response. 1.42. What is the ratio of the Amount of imports(% of total goods imports) in Brazil in 2010 to that in 2011?
Keep it short and to the point. 1.07. What is the ratio of the Amount of imports(% of total goods imports) of Peru in 2010 to that in 2011?
Your response must be concise. 1.01. What is the ratio of the Amount of imports(% of total goods imports) in Brazil in 2010 to that in 2012?
Ensure brevity in your answer.  1.07. What is the ratio of the Amount of imports(% of total goods imports) in Peru in 2010 to that in 2012?
Offer a terse response. 0.96. What is the ratio of the Amount of imports(% of total goods imports) of Belarus in 2011 to that in 2012?
Your response must be concise. 0.7. What is the ratio of the Amount of imports(% of total goods imports) in Brazil in 2011 to that in 2012?
Offer a terse response. 1. What is the ratio of the Amount of imports(% of total goods imports) in Peru in 2011 to that in 2012?
Keep it short and to the point. 0.95. What is the difference between the highest and the second highest Amount of imports(% of total goods imports) of Belarus?
Keep it short and to the point. 0.17. What is the difference between the highest and the second highest Amount of imports(% of total goods imports) of Brazil?
Ensure brevity in your answer.  0.29. What is the difference between the highest and the second highest Amount of imports(% of total goods imports) in Peru?
Offer a terse response. 0.31. What is the difference between the highest and the lowest Amount of imports(% of total goods imports) in Belarus?
Your answer should be compact. 0.9. What is the difference between the highest and the lowest Amount of imports(% of total goods imports) of Brazil?
Ensure brevity in your answer.  7.52. What is the difference between the highest and the lowest Amount of imports(% of total goods imports) of Peru?
Your answer should be compact. 1.56. 